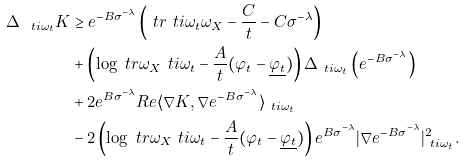Convert formula to latex. <formula><loc_0><loc_0><loc_500><loc_500>\Delta _ { \ t i { \omega } _ { t } } K & \geq e ^ { - B \sigma ^ { - \lambda } } \left ( \ t r { \ t i { \omega } _ { t } } { \omega _ { X } } - \frac { C } { t } - C \sigma ^ { - \lambda } \right ) \\ & + \left ( \log \ t r { \omega _ { X } } { \ t i { \omega } _ { t } } - \frac { A } { t } ( \varphi _ { t } - \underline { \varphi _ { t } } ) \right ) \Delta _ { \ t i { \omega } _ { t } } \left ( e ^ { - B \sigma ^ { - \lambda } } \right ) \\ & + 2 e ^ { B \sigma ^ { - \lambda } } R e \langle \nabla K , \nabla e ^ { - B \sigma ^ { - \lambda } } \rangle _ { \ t i { \omega } _ { t } } \\ & - 2 \left ( \log \ t r { \omega _ { X } } { \ t i { \omega } _ { t } } - \frac { A } { t } ( \varphi _ { t } - \underline { \varphi _ { t } } ) \right ) e ^ { B \sigma ^ { - \lambda } } | \nabla e ^ { - B \sigma ^ { - \lambda } } | ^ { 2 } _ { \ t i { \omega } _ { t } } .</formula> 